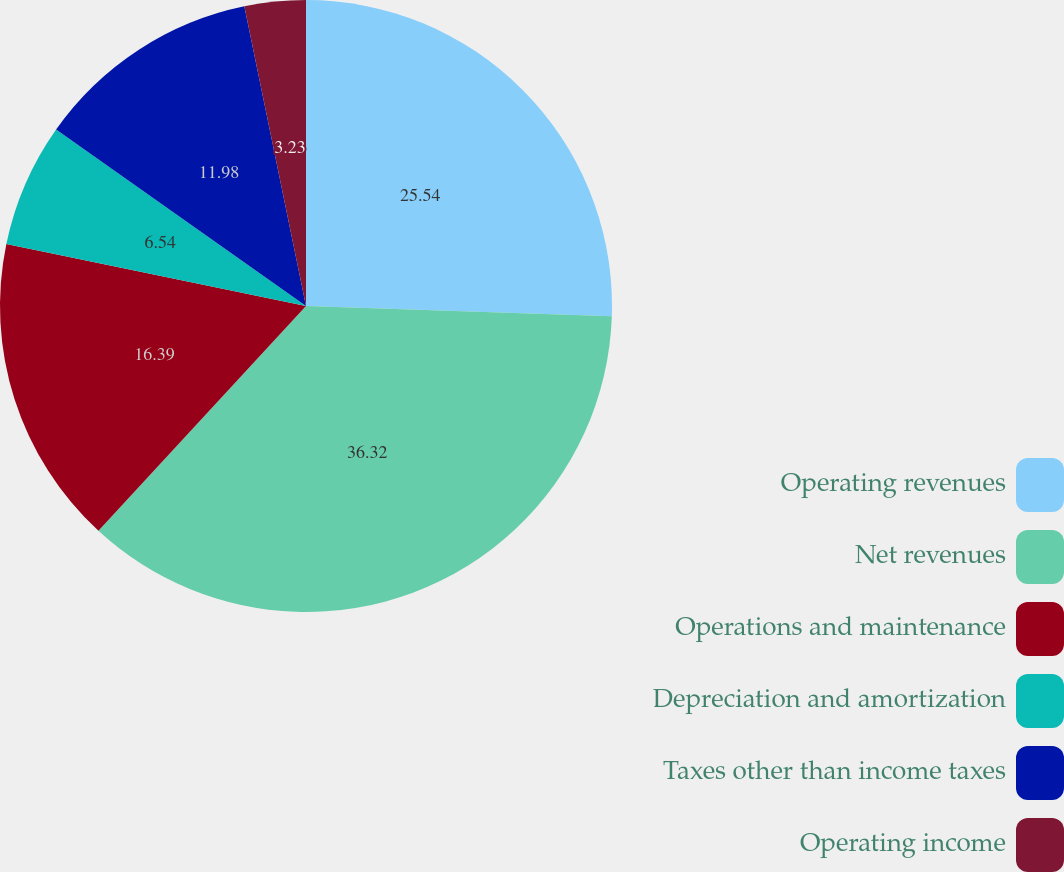Convert chart. <chart><loc_0><loc_0><loc_500><loc_500><pie_chart><fcel>Operating revenues<fcel>Net revenues<fcel>Operations and maintenance<fcel>Depreciation and amortization<fcel>Taxes other than income taxes<fcel>Operating income<nl><fcel>25.54%<fcel>36.33%<fcel>16.39%<fcel>6.54%<fcel>11.98%<fcel>3.23%<nl></chart> 